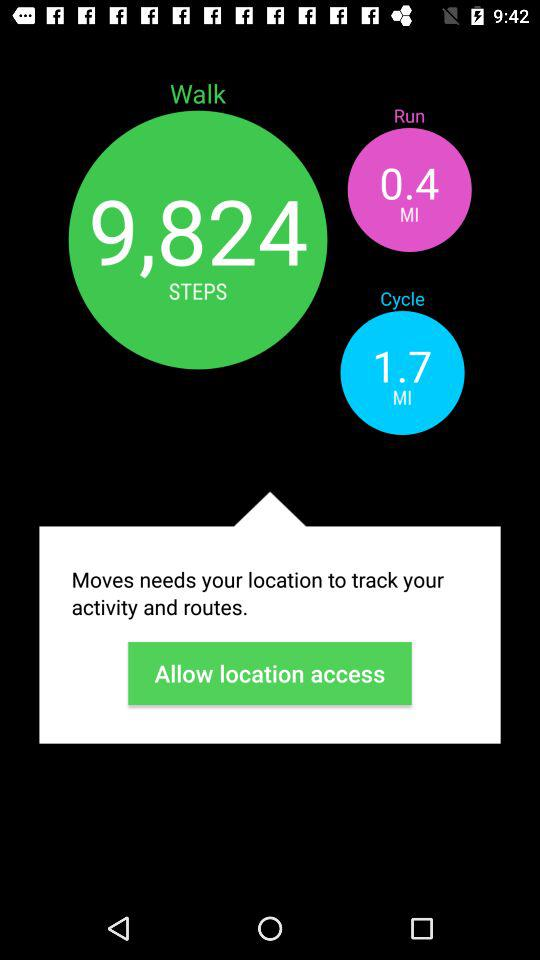What is the count of steps? The count of steps is 9,824. 